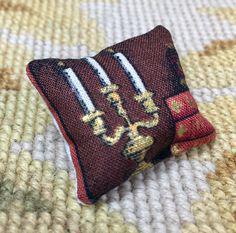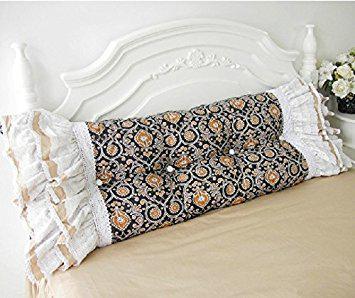The first image is the image on the left, the second image is the image on the right. For the images displayed, is the sentence "There is a child on top of the pillow in at least one of the images." factually correct? Answer yes or no. No. 